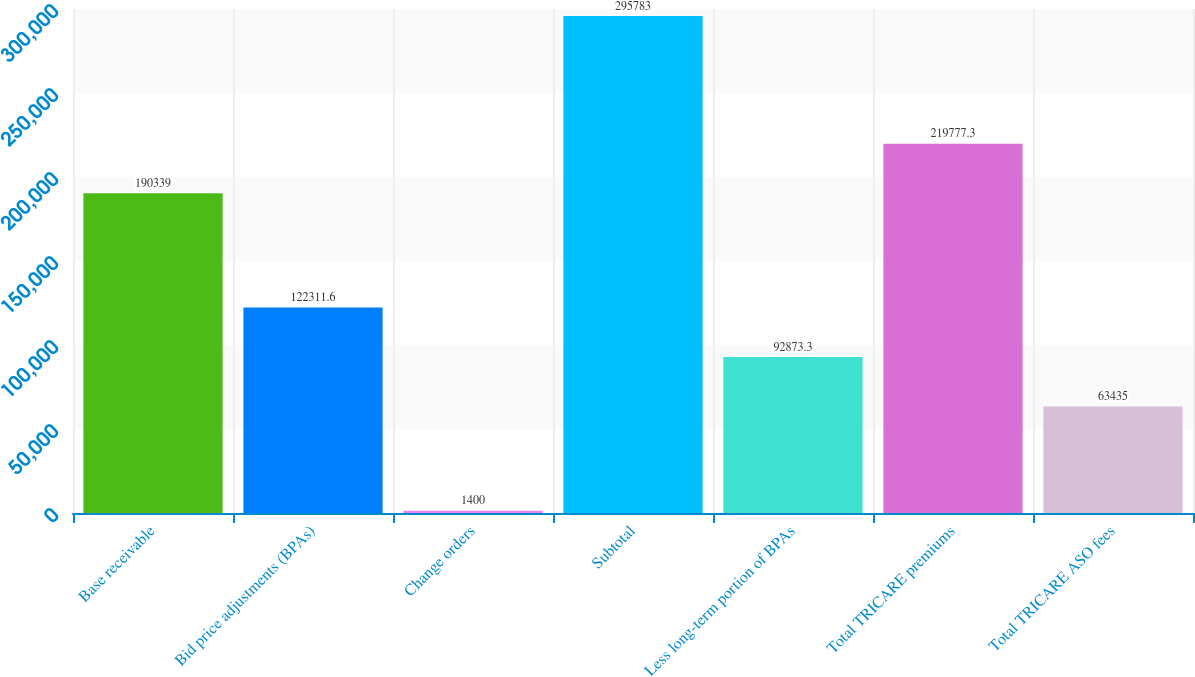<chart> <loc_0><loc_0><loc_500><loc_500><bar_chart><fcel>Base receivable<fcel>Bid price adjustments (BPAs)<fcel>Change orders<fcel>Subtotal<fcel>Less long-term portion of BPAs<fcel>Total TRICARE premiums<fcel>Total TRICARE ASO fees<nl><fcel>190339<fcel>122312<fcel>1400<fcel>295783<fcel>92873.3<fcel>219777<fcel>63435<nl></chart> 